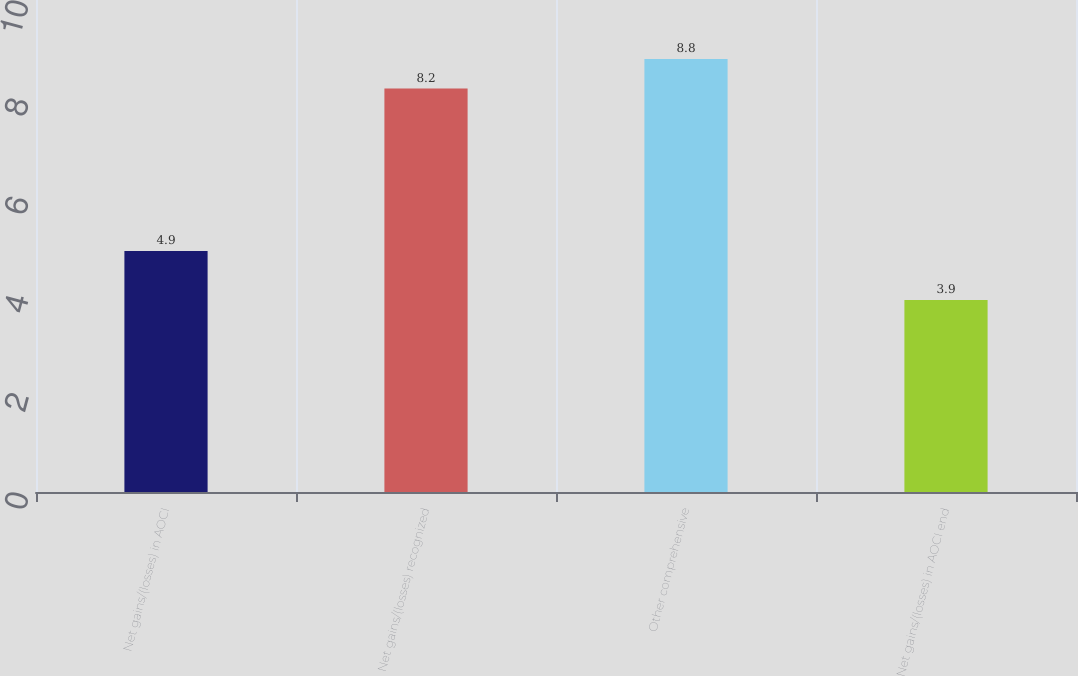Convert chart to OTSL. <chart><loc_0><loc_0><loc_500><loc_500><bar_chart><fcel>Net gains/(losses) in AOCI<fcel>Net gains/(losses) recognized<fcel>Other comprehensive<fcel>Net gains/(losses) in AOCI end<nl><fcel>4.9<fcel>8.2<fcel>8.8<fcel>3.9<nl></chart> 